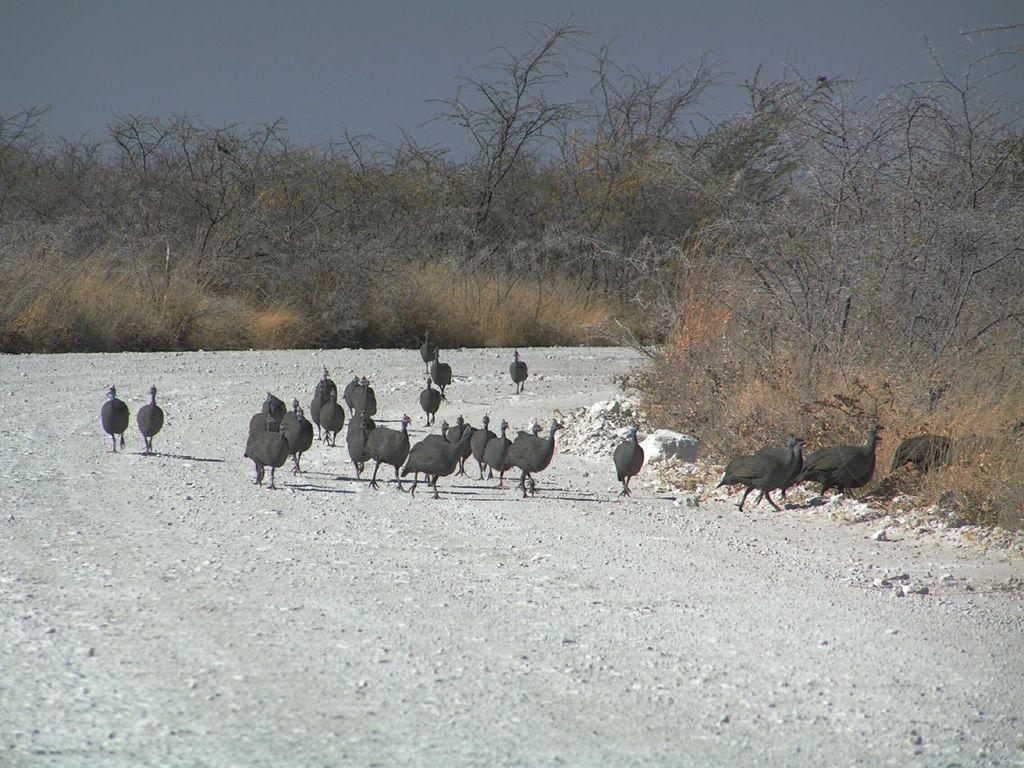Can you describe this image briefly? This picture is clicked outside. In the center we can see the group of birds seems to be running on the ground. In the background we can see the dry stems and the sky. 